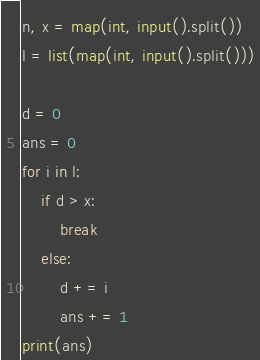Convert code to text. <code><loc_0><loc_0><loc_500><loc_500><_Python_>n, x = map(int, input().split())
l = list(map(int, input().split()))

d = 0
ans = 0
for i in l:
    if d > x:
        break
    else:
        d += i
        ans += 1
print(ans)</code> 